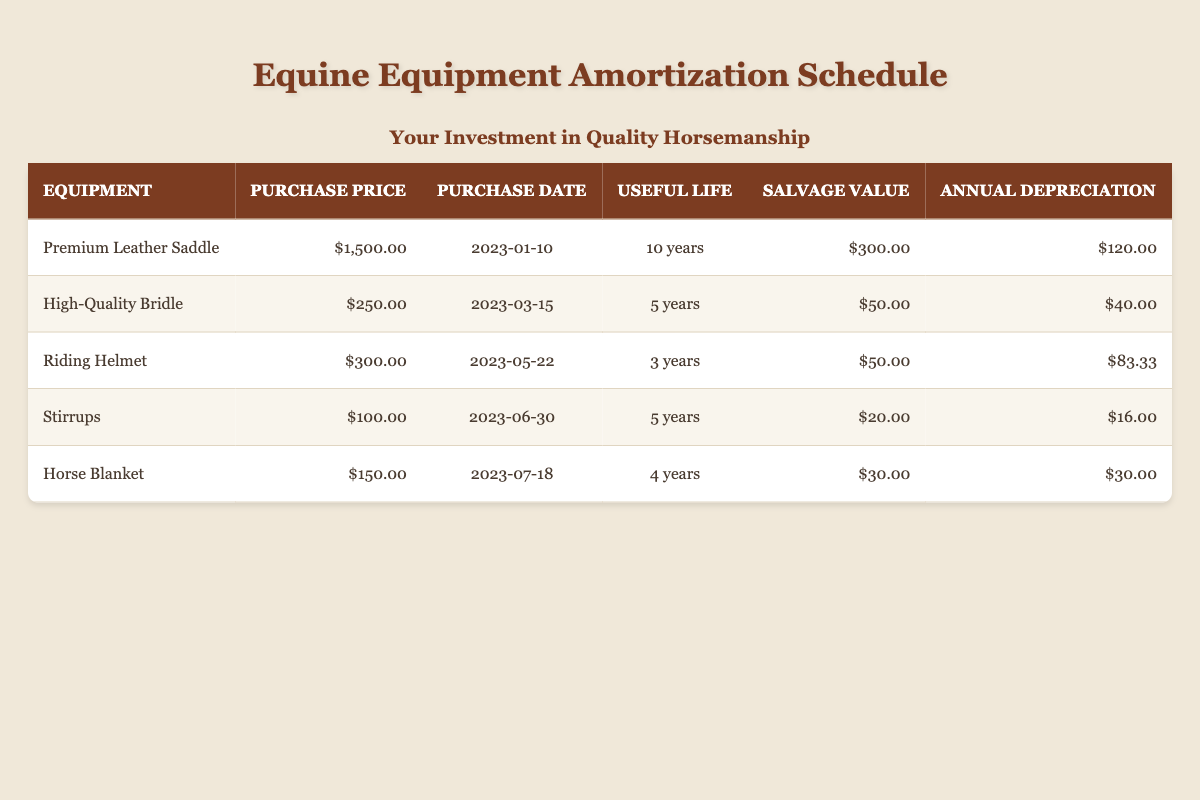What is the purchase price of the Premium Leather Saddle? The table lists the Premium Leather Saddle under the Equipment column, and its corresponding purchase price is shown in the Purchase Price column as $1,500.00.
Answer: $1,500.00 How many years is the useful life of the High-Quality Bridle? In the table, the High-Quality Bridle is listed, and its useful life is indicated in the Useful Life column as 5 years.
Answer: 5 years What is the total annual depreciation for all the equipment? To find the total annual depreciation, we need to sum the Annual Depreciation for each piece of equipment: $120.00 (Saddle) + $40.00 (Bridle) + $83.33 (Helmet) + $16.00 (Stirrups) + $30.00 (Blanket) = $289.33.
Answer: $289.33 Is the salvage value of the Riding Helmet greater than the purchase price? The salvage value of the Riding Helmet is listed as $50.00, while its purchase price is $300.00. Since $50.00 is not greater than $300.00, the statement is false.
Answer: No What is the average useful life of all the equipment? To find the average useful life, sum the useful lives of all items: 10 (Saddle) + 5 (Bridle) + 3 (Helmet) + 5 (Stirrups) + 4 (Blanket) = 27 years. There are 5 pieces of equipment, so the average is 27 years / 5 = 5.4 years.
Answer: 5.4 years What equipment has the highest annual depreciation? Reviewing the Annual Depreciation column, we see $120.00 (Saddle), $40.00 (Bridle), $83.33 (Helmet), $16.00 (Stirrups), and $30.00 (Blanket). The highest amount is $120.00 for the Premium Leather Saddle.
Answer: Premium Leather Saddle What is the total purchase price of the equipment that has a useful life of at least 5 years? The equipment with a useful life of at least 5 years are the Premium Leather Saddle (10 years) and the High-Quality Bridle (5 years) and Stirrups (5 years). Summing their prices gives $1,500.00 + $250.00 + $100.00 = $1,850.00.
Answer: $1,850.00 Is there any equipment that has a salvage value greater than $25.00? Checking the Salvage Value column: Saddle ($300.00), Bridle ($50.00), Helmet ($50.00), Stirrups ($20.00), and Blanket ($30.00). The Saddle, Bridle, Helmet, and Blanket have salvage values greater than $25.00. Therefore, the statement is true.
Answer: Yes 